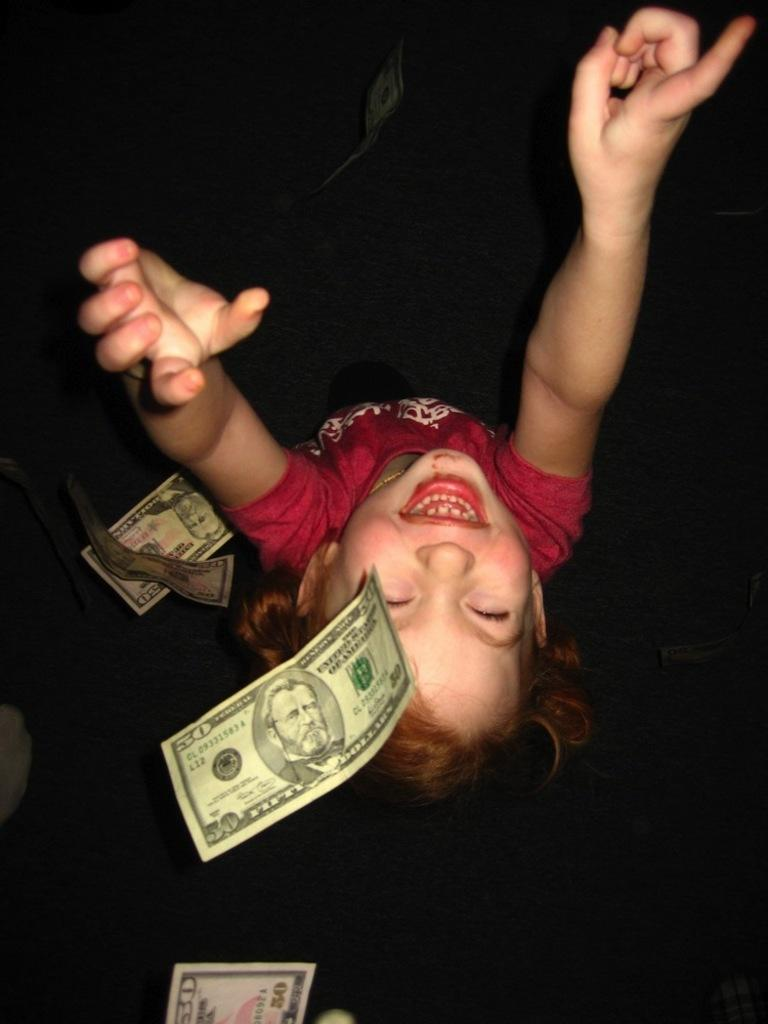Who is the main subject in the image? There is a girl in the image. What is the girl wearing? The girl is wearing a pink shirt. What can be seen on the left side of the image? There are currency notes on the left side of the image. What type of pest can be seen crawling on the girl's pink shirt in the image? There is no pest visible on the girl's pink shirt in the image. How much tax is being paid with the currency notes in the image? The image does not provide information about the tax being paid with the currency notes. 